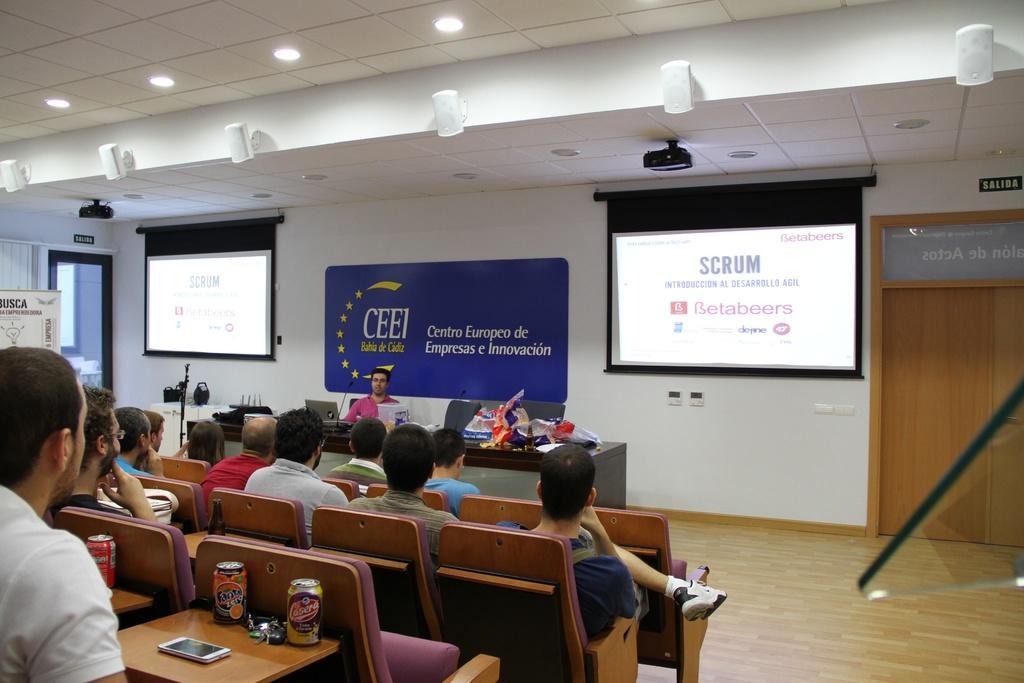Describe this image in one or two sentences. A room where we can see a group of people sitting on the chairs and there are two projectors and screens in the room and some speakers in the room. 